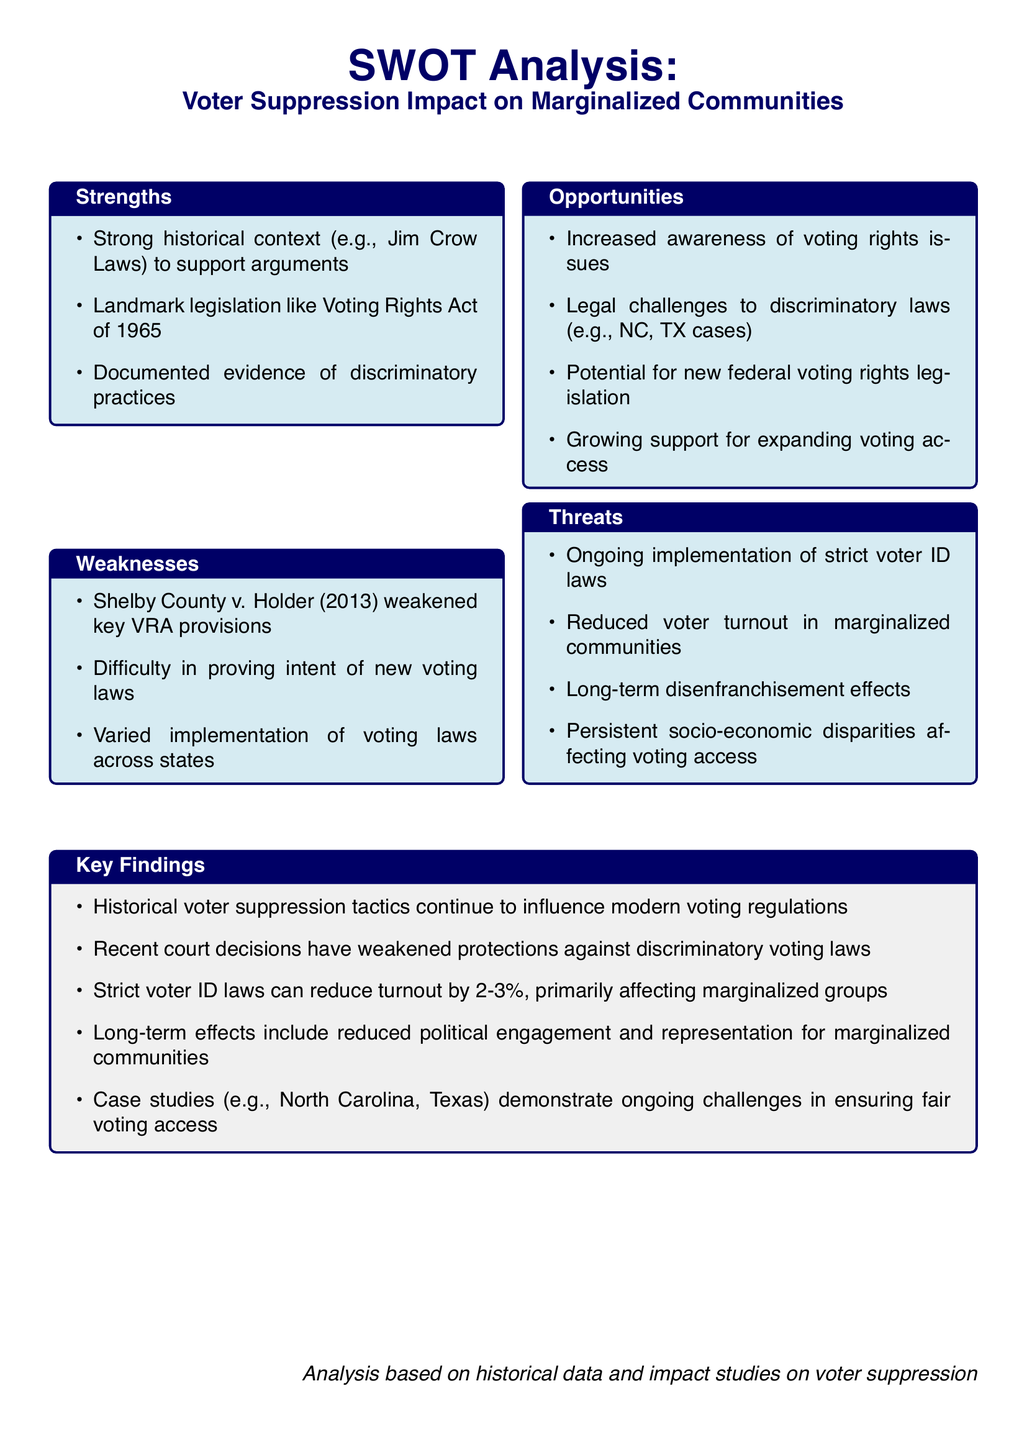What landmark legislation is mentioned in the document? The document references the Voting Rights Act of 1965 as a significant piece of legislation in the context of voter suppression.
Answer: Voting Rights Act of 1965 Which court case weakened provisions of the Voting Rights Act? The document cites Shelby County v. Holder (2013) as a case that weakened important VRA provisions.
Answer: Shelby County v. Holder What percentage reduction in turnout is associated with strict voter ID laws? The document mentions that strict voter ID laws can reduce turnout by 2-3%.
Answer: 2-3% What is one of the key findings regarding voter suppression tactics? The document states that historical voter suppression tactics continue to influence modern voting regulations.
Answer: Influence on modern voting regulations What is a major threat to marginalized communities mentioned in the document? The document lists the ongoing implementation of strict voter ID laws as a significant threat to marginalized communities.
Answer: Strict voter ID laws What opportunity is mentioned in the document relating to voting rights? The document highlights increased awareness of voting rights issues as an opportunity.
Answer: Increased awareness of voting rights issues 